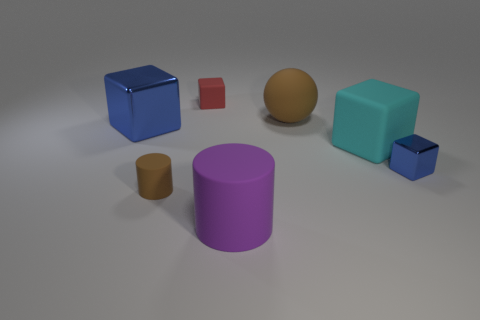Subtract 1 cubes. How many cubes are left? 3 Subtract all yellow blocks. Subtract all yellow balls. How many blocks are left? 4 Add 1 large purple cylinders. How many objects exist? 8 Subtract all spheres. How many objects are left? 6 Add 3 small brown cylinders. How many small brown cylinders exist? 4 Subtract 0 red cylinders. How many objects are left? 7 Subtract all small rubber cylinders. Subtract all big brown rubber spheres. How many objects are left? 5 Add 4 big blue things. How many big blue things are left? 5 